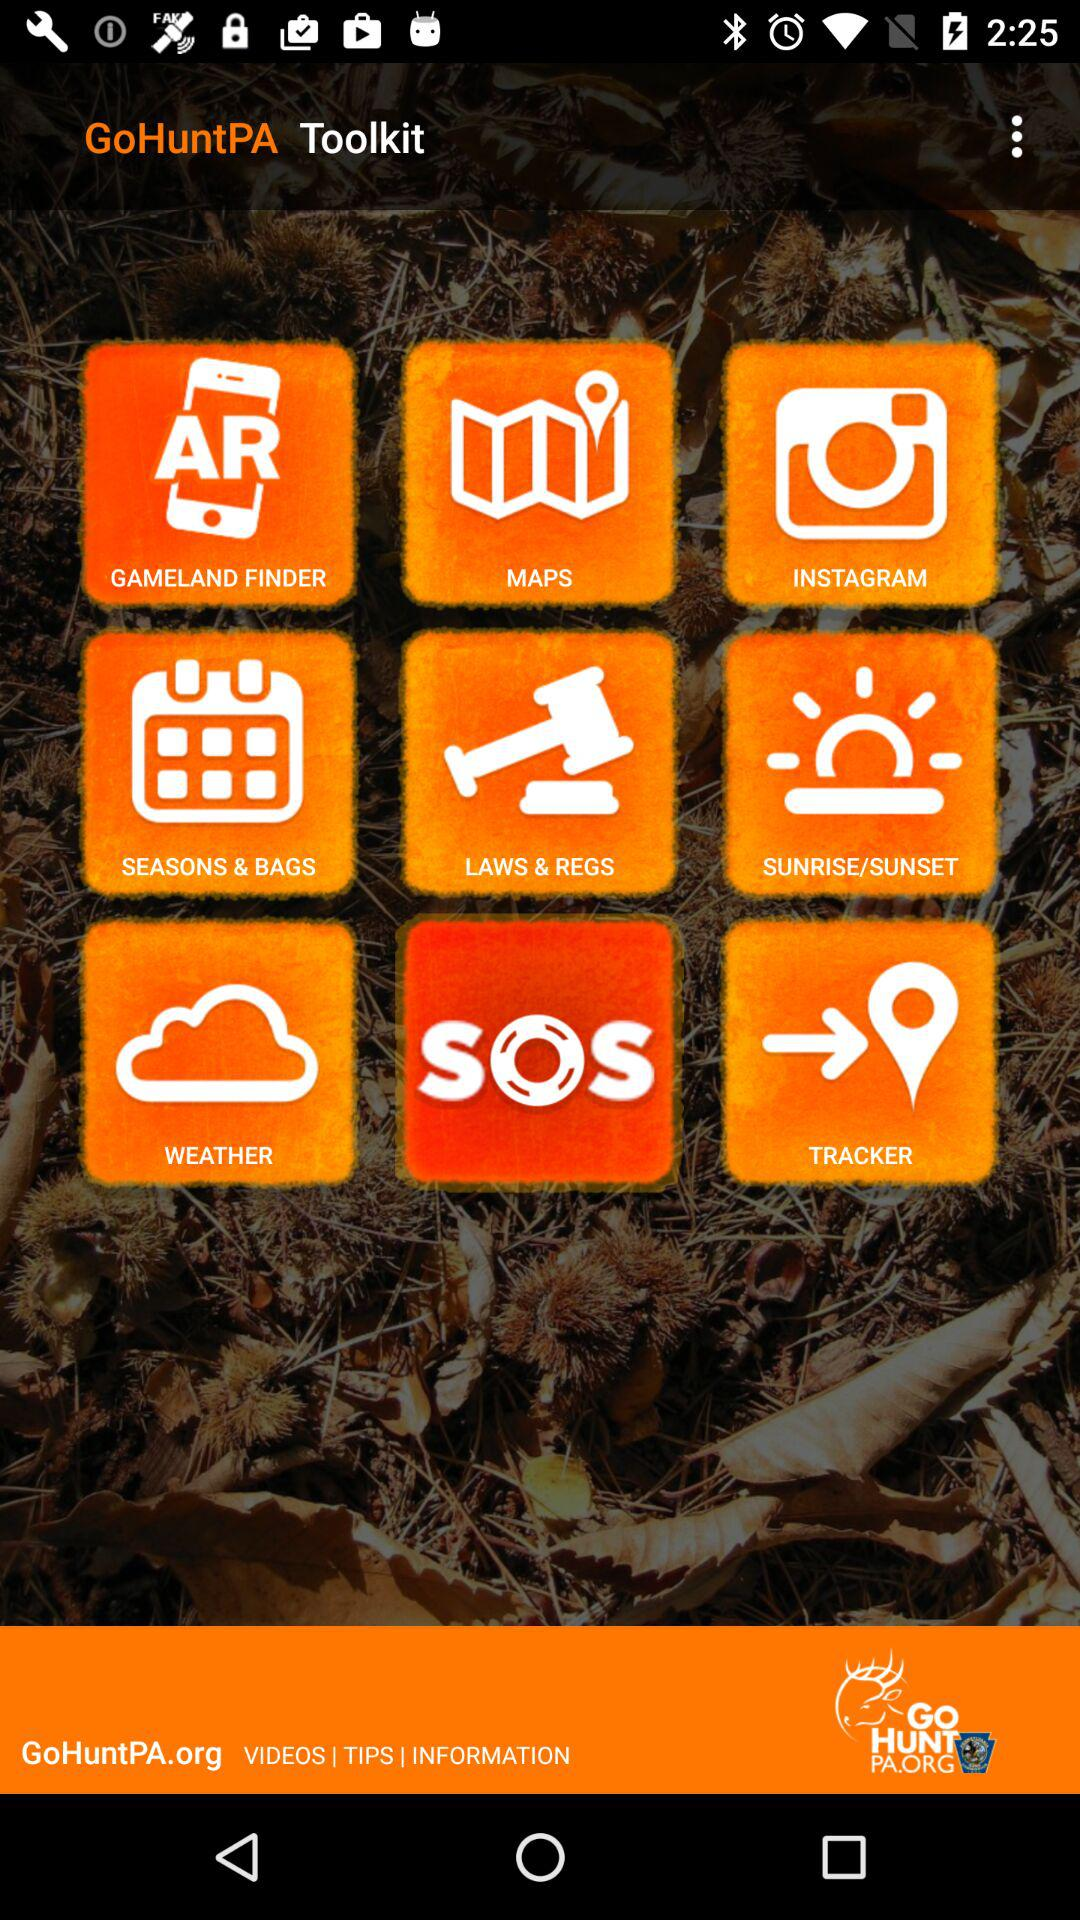What is the name of the application? The application name is "GoHuntPA Toolkit". 